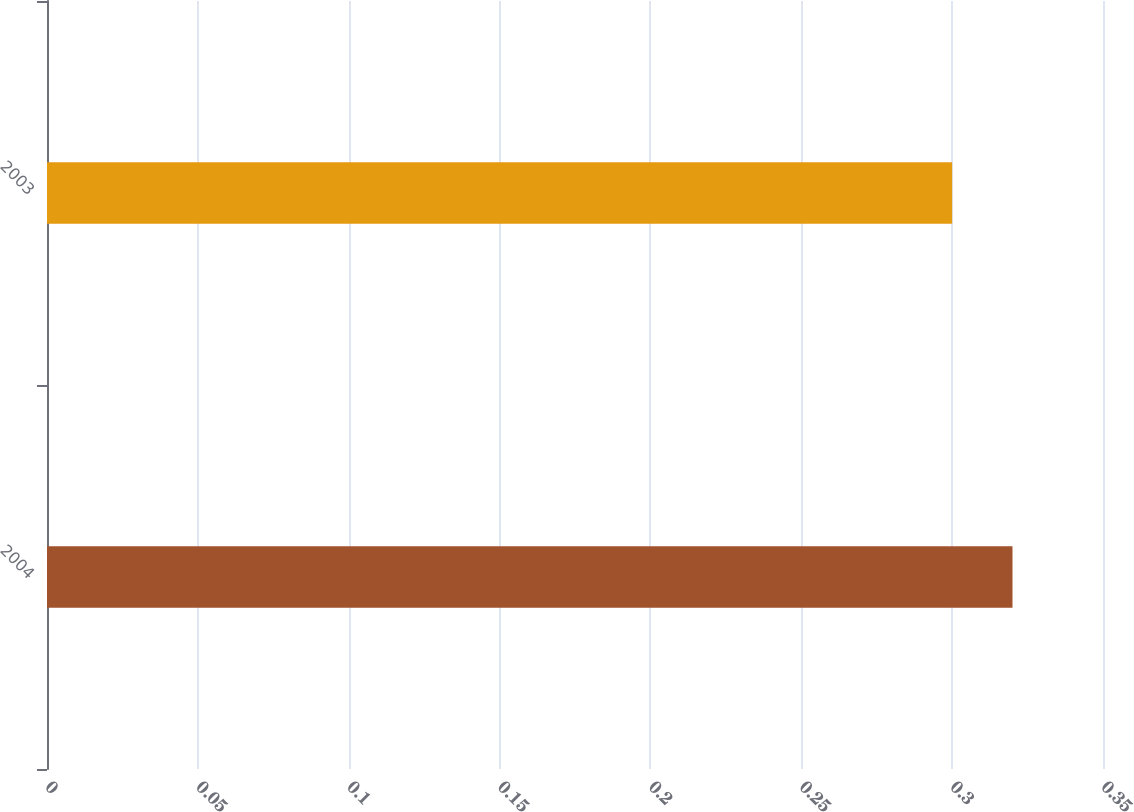<chart> <loc_0><loc_0><loc_500><loc_500><bar_chart><fcel>2004<fcel>2003<nl><fcel>0.32<fcel>0.3<nl></chart> 